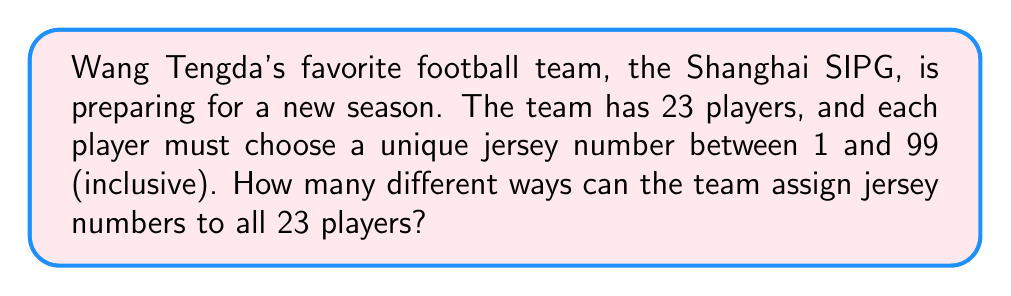Could you help me with this problem? Let's approach this step-by-step:

1) This is a combination problem where we need to select 23 numbers out of 99 possible numbers, and the order doesn't matter (since we're not assigning specific numbers to specific players).

2) The formula for combinations is:

   $$C(n,r) = \frac{n!}{r!(n-r)!}$$

   where $n$ is the total number of items to choose from, and $r$ is the number of items being chosen.

3) In this case, $n = 99$ (total numbers available) and $r = 23$ (number of players).

4) Plugging these values into our formula:

   $$C(99,23) = \frac{99!}{23!(99-23)!} = \frac{99!}{23!76!}$$

5) This can be calculated as:

   $$\frac{99 \times 98 \times 97 \times ... \times 78 \times 77}{23 \times 22 \times 21 \times ... \times 2 \times 1}$$

6) Using a calculator or computer to evaluate this large number, we get:

   $$C(99,23) = 90,087,757,743,616,475,336,725$$

Therefore, there are 90,087,757,743,616,475,336,725 different ways for the Shanghai SIPG team to assign jersey numbers to their 23 players.
Answer: $90,087,757,743,616,475,336,725$ 